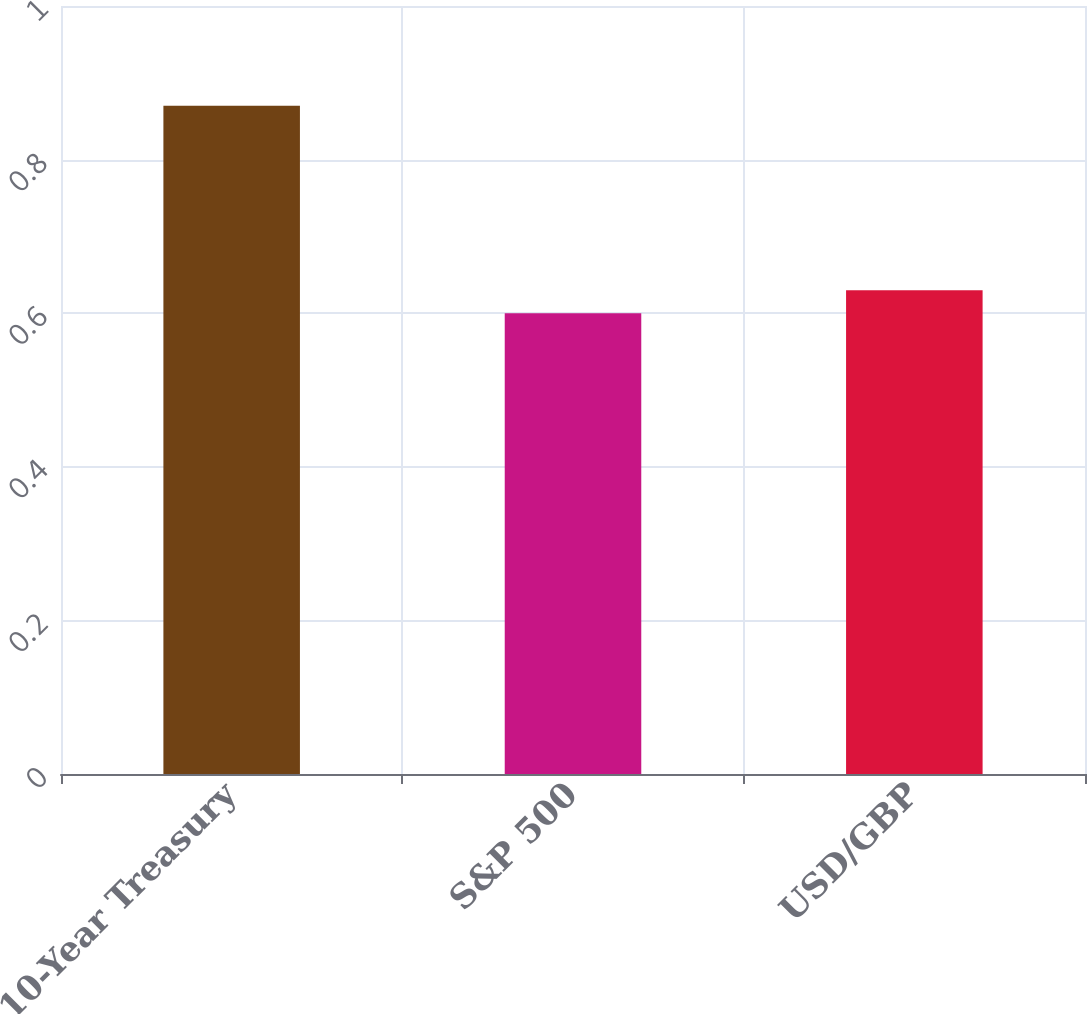Convert chart. <chart><loc_0><loc_0><loc_500><loc_500><bar_chart><fcel>10-Year Treasury<fcel>S&P 500<fcel>USD/GBP<nl><fcel>0.87<fcel>0.6<fcel>0.63<nl></chart> 